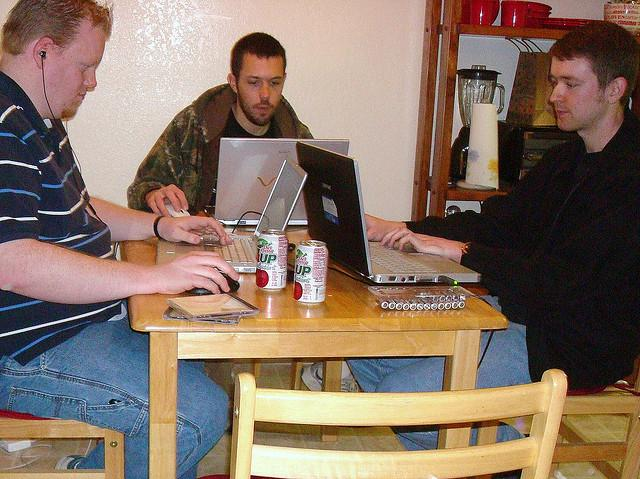Why are they all there together?

Choices:
A) hiding
B) fighting
C) eating lunch
D) sharing table sharing table 